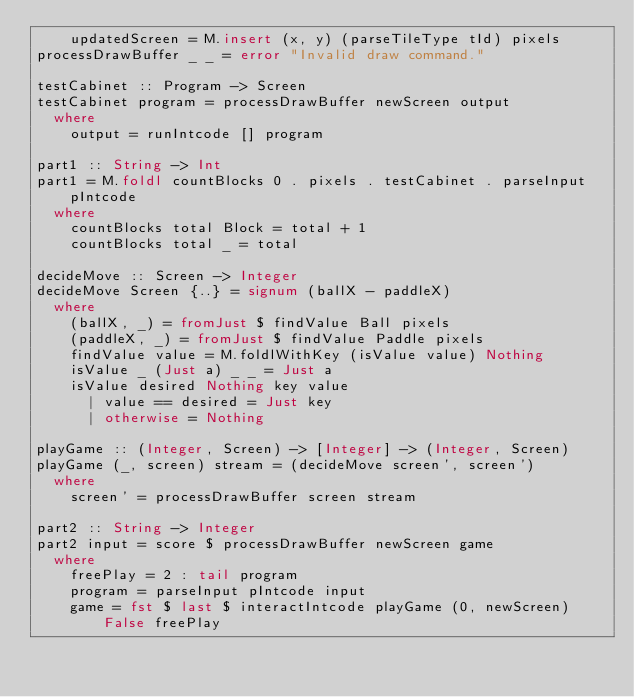Convert code to text. <code><loc_0><loc_0><loc_500><loc_500><_Haskell_>    updatedScreen = M.insert (x, y) (parseTileType tId) pixels
processDrawBuffer _ _ = error "Invalid draw command."

testCabinet :: Program -> Screen
testCabinet program = processDrawBuffer newScreen output
  where
    output = runIntcode [] program

part1 :: String -> Int
part1 = M.foldl countBlocks 0 . pixels . testCabinet . parseInput pIntcode
  where
    countBlocks total Block = total + 1
    countBlocks total _ = total

decideMove :: Screen -> Integer
decideMove Screen {..} = signum (ballX - paddleX)
  where
    (ballX, _) = fromJust $ findValue Ball pixels
    (paddleX, _) = fromJust $ findValue Paddle pixels
    findValue value = M.foldlWithKey (isValue value) Nothing
    isValue _ (Just a) _ _ = Just a
    isValue desired Nothing key value
      | value == desired = Just key
      | otherwise = Nothing

playGame :: (Integer, Screen) -> [Integer] -> (Integer, Screen)
playGame (_, screen) stream = (decideMove screen', screen')
  where
    screen' = processDrawBuffer screen stream

part2 :: String -> Integer
part2 input = score $ processDrawBuffer newScreen game
  where
    freePlay = 2 : tail program
    program = parseInput pIntcode input
    game = fst $ last $ interactIntcode playGame (0, newScreen) False freePlay
</code> 